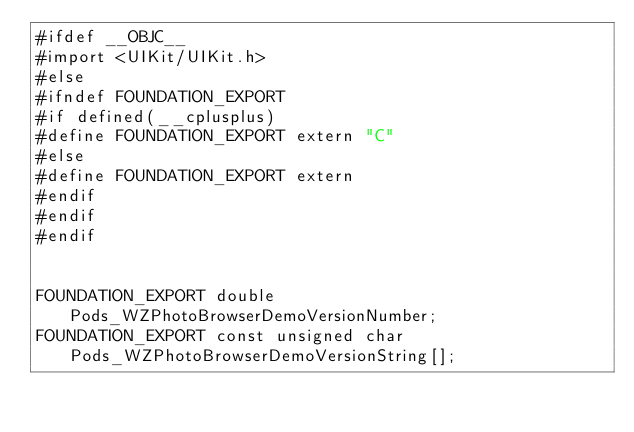<code> <loc_0><loc_0><loc_500><loc_500><_C_>#ifdef __OBJC__
#import <UIKit/UIKit.h>
#else
#ifndef FOUNDATION_EXPORT
#if defined(__cplusplus)
#define FOUNDATION_EXPORT extern "C"
#else
#define FOUNDATION_EXPORT extern
#endif
#endif
#endif


FOUNDATION_EXPORT double Pods_WZPhotoBrowserDemoVersionNumber;
FOUNDATION_EXPORT const unsigned char Pods_WZPhotoBrowserDemoVersionString[];

</code> 